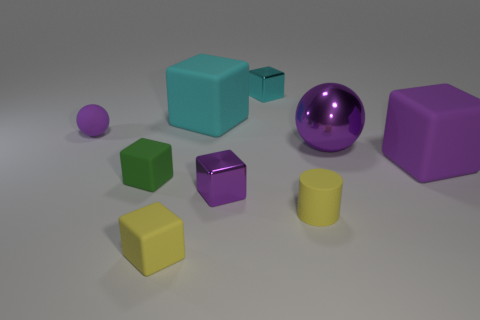Subtract all yellow cubes. How many cubes are left? 5 Subtract 3 cubes. How many cubes are left? 3 Subtract all large purple cubes. How many cubes are left? 5 Subtract all green blocks. Subtract all brown balls. How many blocks are left? 5 Add 1 tiny things. How many objects exist? 10 Subtract all spheres. How many objects are left? 7 Add 6 large spheres. How many large spheres are left? 7 Add 5 tiny cyan cubes. How many tiny cyan cubes exist? 6 Subtract 0 gray balls. How many objects are left? 9 Subtract all big cyan shiny blocks. Subtract all yellow matte cubes. How many objects are left? 8 